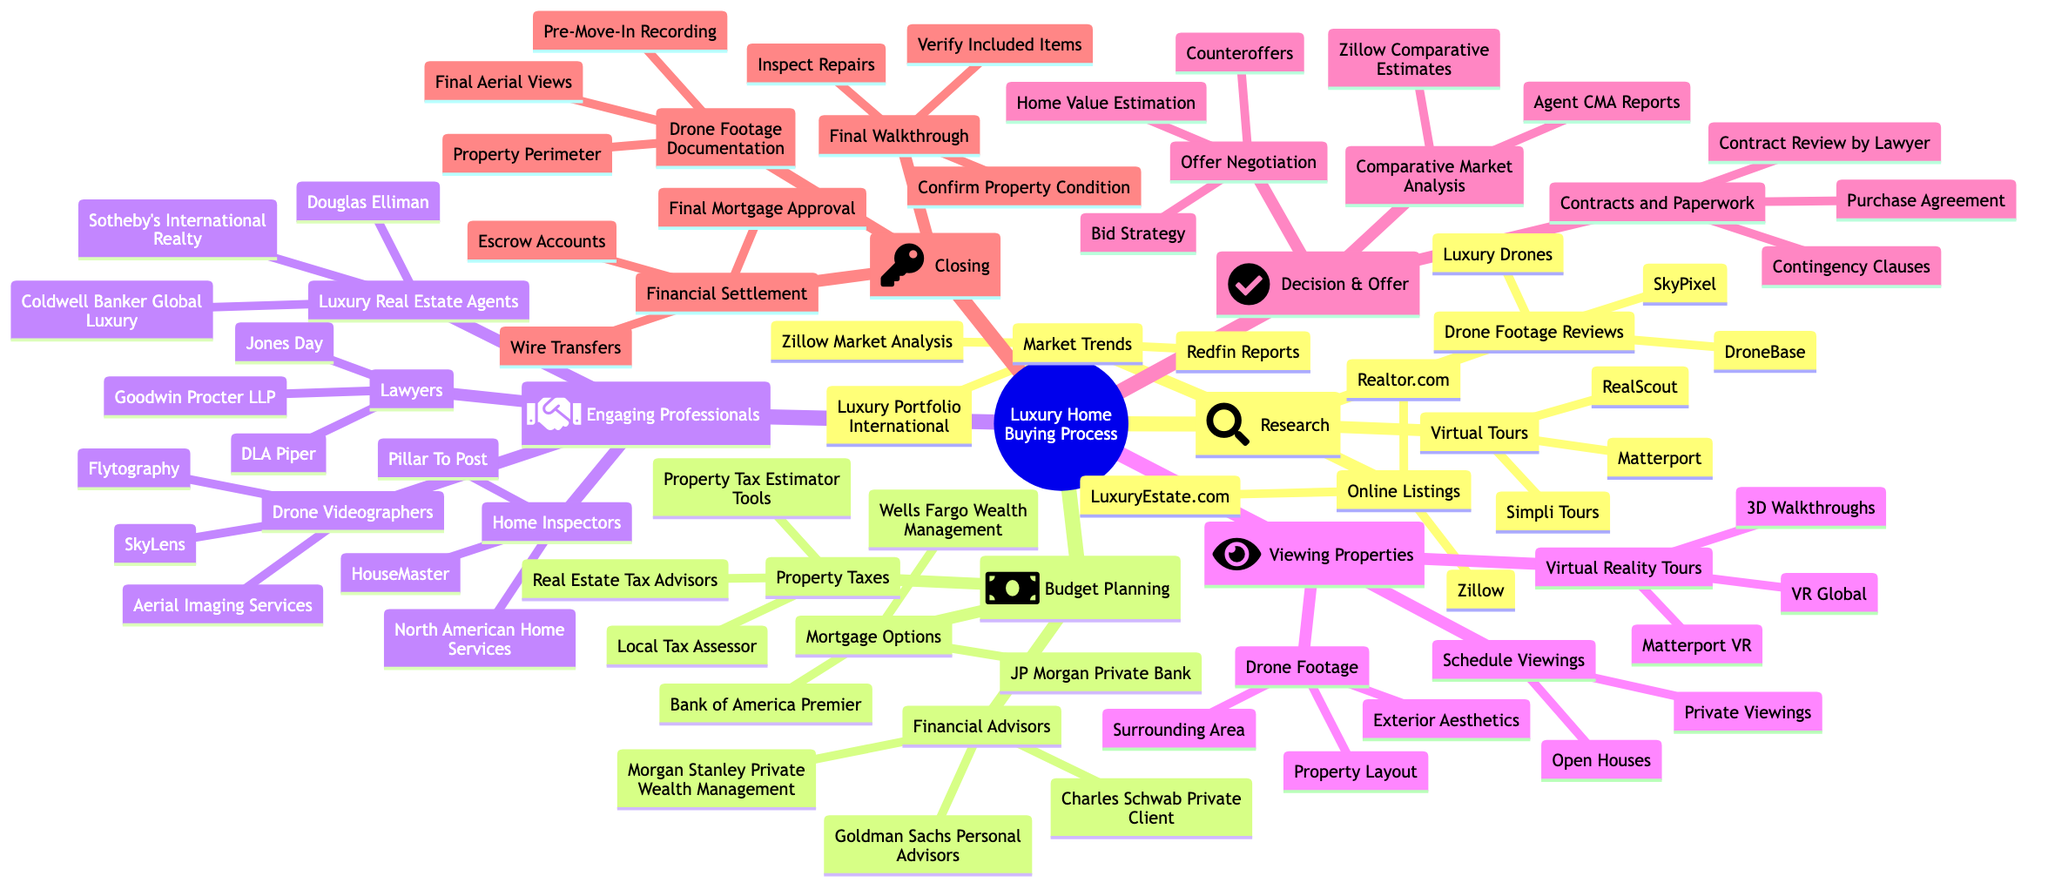What is the first step in the luxury home buying process? The first step is "Research," which is the initial node connected directly to the root of the mind map.
Answer: Research How many mortgage options are listed under Budget Planning? There are three mortgage options listed: JP Morgan Private Bank, Wells Fargo Wealth Management, and Bank of America Premier. This is verified by counting the nodes under Budget Planning.
Answer: 3 What type of professionals are included in the Engaging Professionals section? The Engaging Professionals section includes Luxury Real Estate Agents, Home Inspectors, Lawyers, and Drone Videographers. The answer involves looking at the main branches under this section.
Answer: Luxury Real Estate Agents, Home Inspectors, Lawyers, Drone Videographers Which category follows Viewing Properties? The category that follows Viewing Properties is "Decision & Offer." This can be determined by reading the order of the nodes in the diagram.
Answer: Decision & Offer What are the three aspects covered by Drone Footage in the Viewing Properties section? The three aspects covered by Drone Footage are Exterior Aesthetics, Surrounding Area, and Property Layout, found by examining the sub-nodes of the Viewing Properties section.
Answer: Exterior Aesthetics, Surrounding Area, Property Layout How many options are available under Financial Settlement in the Closing section? There are three options available: Wire Transfers, Escrow Accounts, and Final Mortgage Approval, identified by counting the items listed under the Financial Settlement node.
Answer: 3 What is a key item included in the Decision & Offer section? A key item under Decision & Offer is "Comparative Market Analysis," which is one of the main features listed beneath this section.
Answer: Comparative Market Analysis Which type of service does the Drone Videographers category provide? The Drone Videographers category provides services like Aerial Imaging Services, Flytography, and SkyLens, which can be found under the Engaging Professionals section.
Answer: Aerial Imaging Services, Flytography, SkyLens 